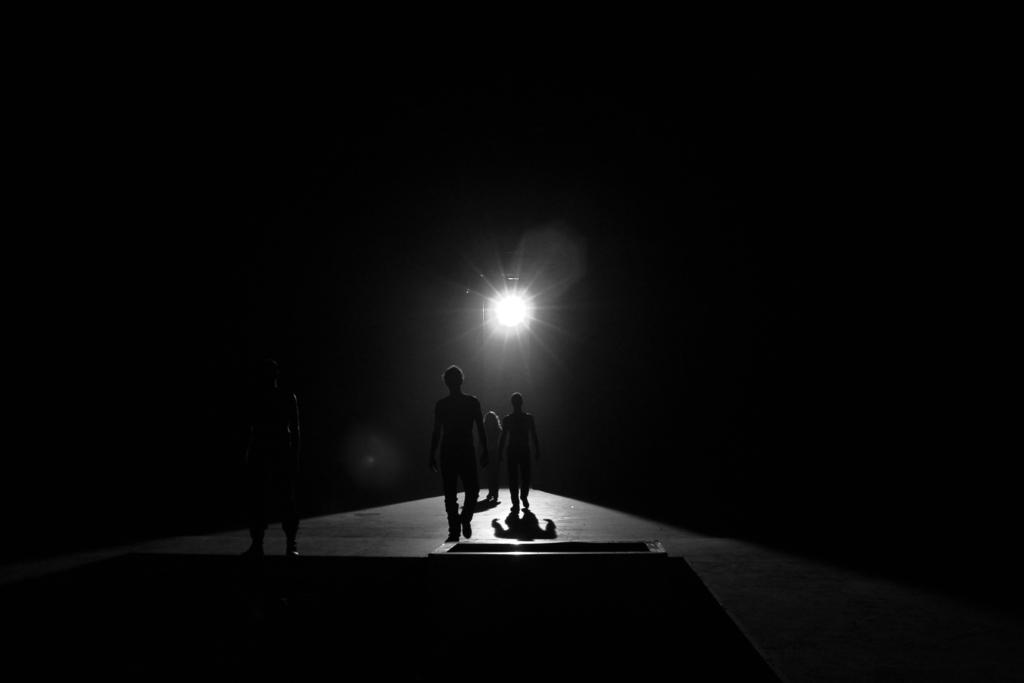What are the people in the image doing? The people in the image are on a path. Can you describe the lighting in the image? There is a light visible in the image. How would you describe the background of the image? The background of the image is a mix of light and dark areas. What health benefits can be gained from the connection in the image? There is no connection present in the image, and therefore no health benefits can be gained from it. 